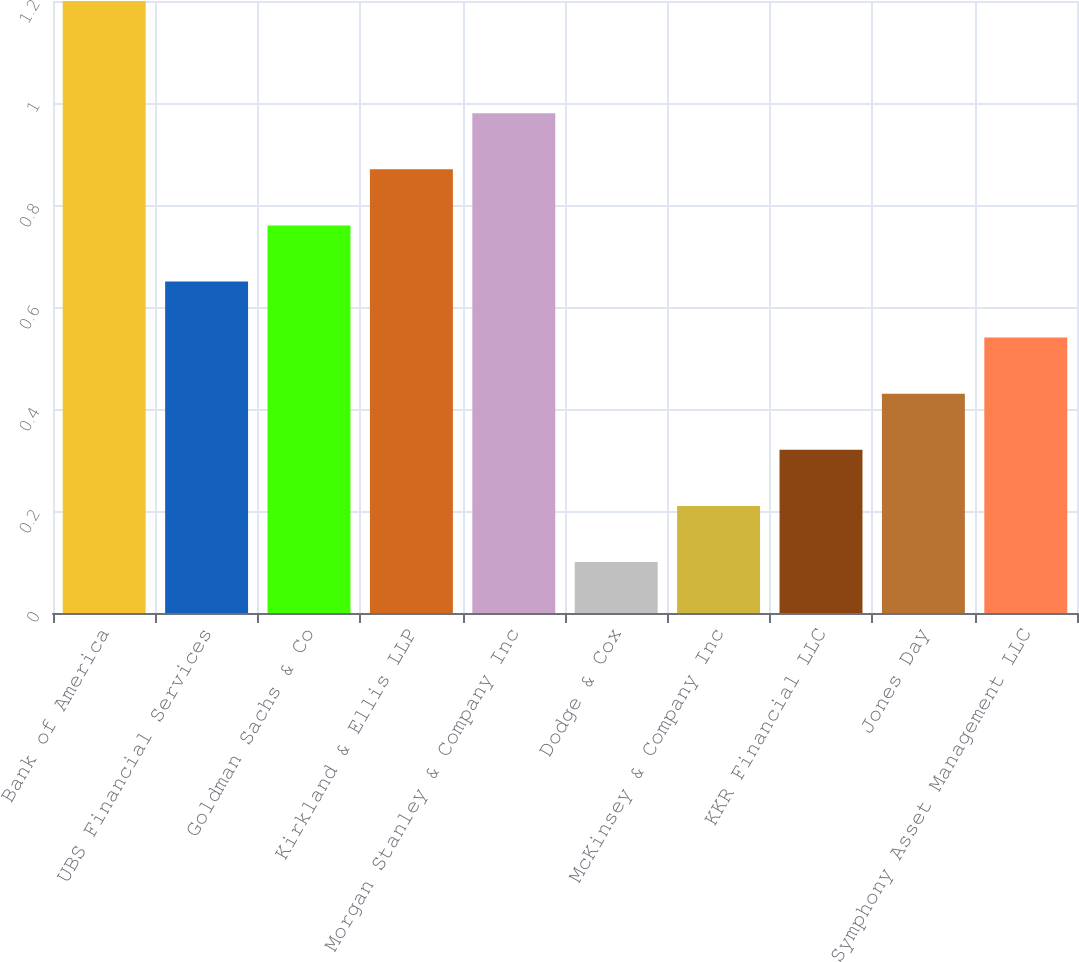<chart> <loc_0><loc_0><loc_500><loc_500><bar_chart><fcel>Bank of America<fcel>UBS Financial Services<fcel>Goldman Sachs & Co<fcel>Kirkland & Ellis LLP<fcel>Morgan Stanley & Company Inc<fcel>Dodge & Cox<fcel>McKinsey & Company Inc<fcel>KKR Financial LLC<fcel>Jones Day<fcel>Symphony Asset Management LLC<nl><fcel>1.2<fcel>0.65<fcel>0.76<fcel>0.87<fcel>0.98<fcel>0.1<fcel>0.21<fcel>0.32<fcel>0.43<fcel>0.54<nl></chart> 